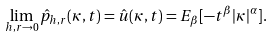<formula> <loc_0><loc_0><loc_500><loc_500>\lim _ { h , r \to 0 } \hat { p } _ { h , r } ( \kappa , t ) = \hat { u } ( \kappa , t ) = E _ { \beta } [ - t ^ { \beta } | \kappa | ^ { \alpha } ] .</formula> 